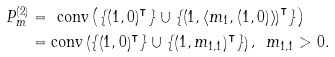Convert formula to latex. <formula><loc_0><loc_0><loc_500><loc_500>P _ { m } ^ { \left ( 2 \right ) } & = \text {\emph{\ }conv} \left ( \left \{ \left ( 1 , 0 \right ) ^ { \intercal } \right \} \cup \left \{ \left ( 1 , \left \langle m _ { 1 } , ( 1 , 0 ) \right \rangle \right ) ^ { \intercal } \right \} \right ) \\ & = \text {conv} \left ( \left \{ \left ( 1 , 0 \right ) ^ { \intercal } \right \} \cup \left \{ \left ( 1 , m _ { 1 , 1 } \right ) ^ { \intercal } \right \} \right ) \text {\emph{, \ }} m _ { 1 , 1 } > 0 .</formula> 